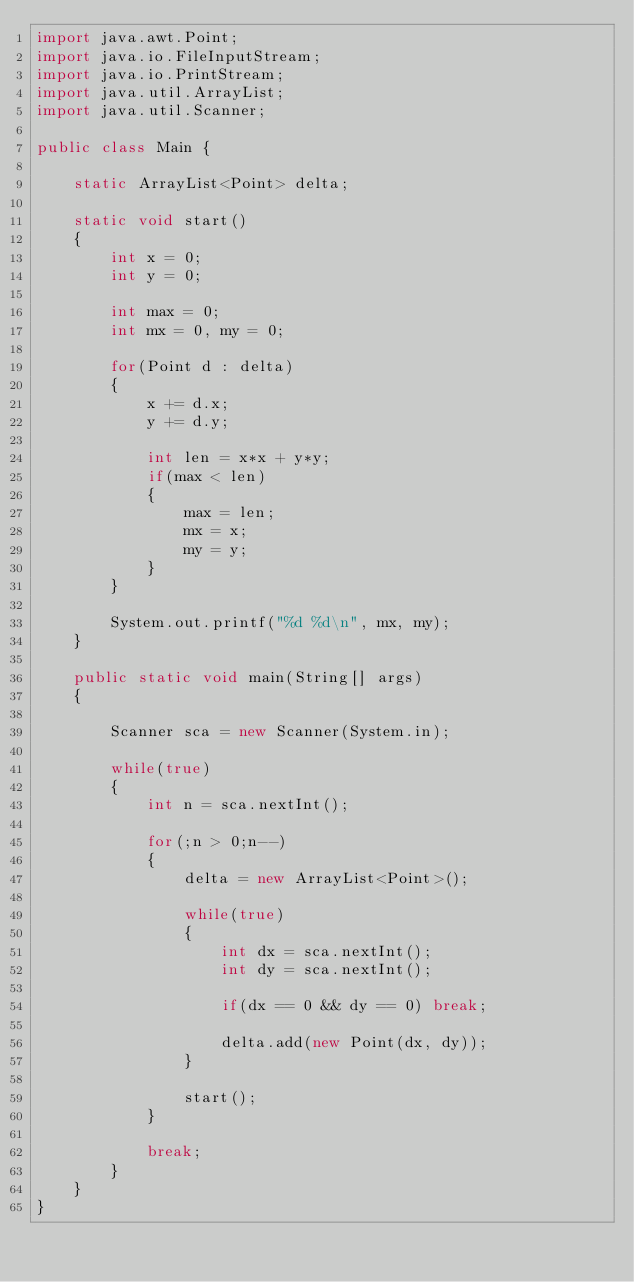<code> <loc_0><loc_0><loc_500><loc_500><_Java_>import java.awt.Point;
import java.io.FileInputStream;
import java.io.PrintStream;
import java.util.ArrayList;
import java.util.Scanner;
 
public class Main {
     
    static ArrayList<Point> delta;
     
    static void start()
    {
        int x = 0;
        int y = 0;
         
        int max = 0;
        int mx = 0, my = 0;
         
        for(Point d : delta)
        {
            x += d.x;
            y += d.y;
             
            int len = x*x + y*y;
            if(max < len)
            {
                max = len;
                mx = x;
                my = y;
            }
        }
         
        System.out.printf("%d %d\n", mx, my);
    }
     
    public static void main(String[] args)
    {
         
        Scanner sca = new Scanner(System.in);
         
        while(true)
        {
            int n = sca.nextInt();
 
            for(;n > 0;n--)
            {
                delta = new ArrayList<Point>();
                 
                while(true)
                {
                    int dx = sca.nextInt();
                    int dy = sca.nextInt();
                     
                    if(dx == 0 && dy == 0) break;
                     
                    delta.add(new Point(dx, dy));
                }
                 
                start();
            }
             
            break;
        }
    }
}</code> 